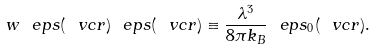<formula> <loc_0><loc_0><loc_500><loc_500>w _ { \ } e p s ( \ v c { r } ) \ e p s ( \ v c { r } ) \equiv \frac { \lambda ^ { 3 } } { 8 \pi k _ { B } } \ e p s _ { 0 } ( \ v c { r } ) .</formula> 